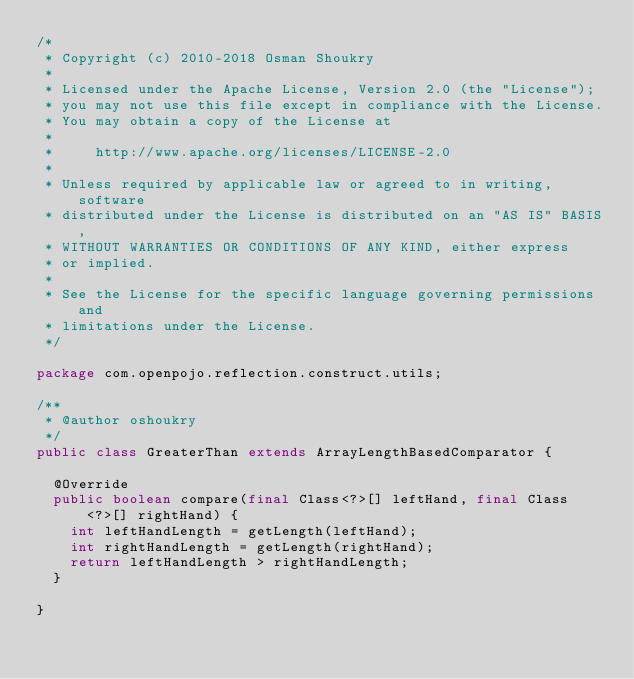Convert code to text. <code><loc_0><loc_0><loc_500><loc_500><_Java_>/*
 * Copyright (c) 2010-2018 Osman Shoukry
 *
 * Licensed under the Apache License, Version 2.0 (the "License");
 * you may not use this file except in compliance with the License.
 * You may obtain a copy of the License at
 *
 *     http://www.apache.org/licenses/LICENSE-2.0
 *
 * Unless required by applicable law or agreed to in writing, software
 * distributed under the License is distributed on an "AS IS" BASIS,
 * WITHOUT WARRANTIES OR CONDITIONS OF ANY KIND, either express
 * or implied.
 *
 * See the License for the specific language governing permissions and
 * limitations under the License.
 */

package com.openpojo.reflection.construct.utils;

/**
 * @author oshoukry
 */
public class GreaterThan extends ArrayLengthBasedComparator {

  @Override
  public boolean compare(final Class<?>[] leftHand, final Class<?>[] rightHand) {
    int leftHandLength = getLength(leftHand);
    int rightHandLength = getLength(rightHand);
    return leftHandLength > rightHandLength;
  }

}
</code> 